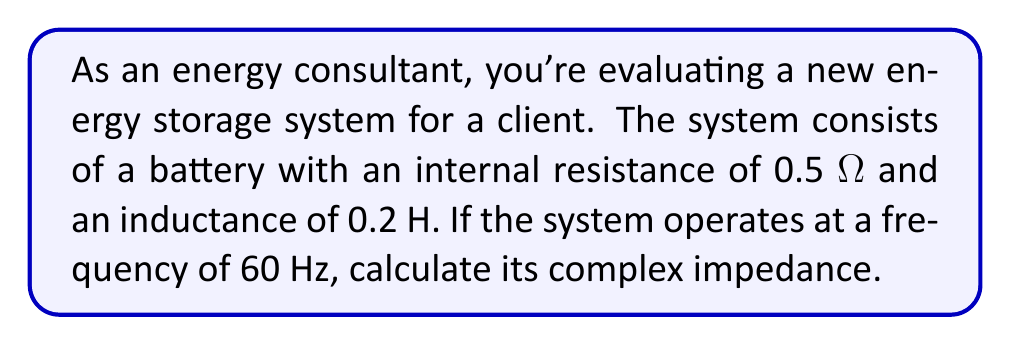Provide a solution to this math problem. To solve this problem, we'll follow these steps:

1) The complex impedance Z of a circuit with resistance R and inductance L is given by:

   $Z = R + j\omega L$

   where $\omega$ is the angular frequency, and $j$ is the imaginary unit.

2) We're given:
   R = 0.5 Ω
   L = 0.2 H
   f = 60 Hz

3) First, we need to calculate $\omega$:
   
   $\omega = 2\pi f = 2\pi(60) = 120\pi$ rad/s

4) Now we can substitute these values into our impedance equation:

   $Z = 0.5 + j(120\pi)(0.2)$

5) Simplify:

   $Z = 0.5 + j75.4$

6) This is our final answer in rectangular form. We can also express it in polar form:

   Magnitude: $|Z| = \sqrt{0.5^2 + 75.4^2} = 75.4$ Ω

   Angle: $\theta = \tan^{-1}(\frac{75.4}{0.5}) = 89.62°$

   So in polar form: $Z = 75.4 \angle 89.62°$ Ω
Answer: $Z = 0.5 + j75.4$ Ω or $75.4 \angle 89.62°$ Ω 